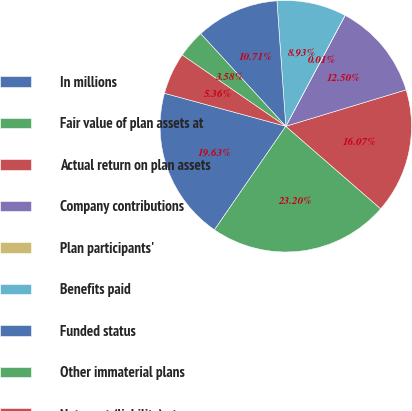<chart> <loc_0><loc_0><loc_500><loc_500><pie_chart><fcel>In millions<fcel>Fair value of plan assets at<fcel>Actual return on plan assets<fcel>Company contributions<fcel>Plan participants'<fcel>Benefits paid<fcel>Funded status<fcel>Other immaterial plans<fcel>Net asset (liability) at<nl><fcel>19.63%<fcel>23.2%<fcel>16.07%<fcel>12.5%<fcel>0.01%<fcel>8.93%<fcel>10.71%<fcel>3.58%<fcel>5.36%<nl></chart> 